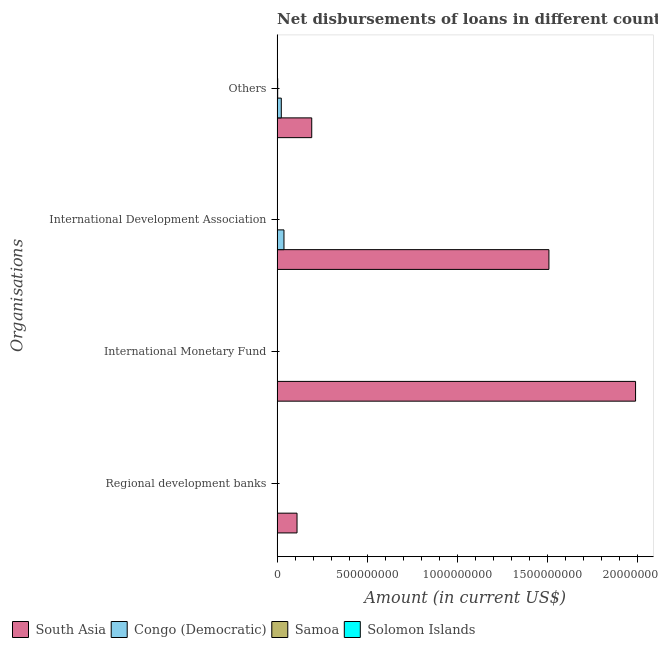How many different coloured bars are there?
Give a very brief answer. 4. How many groups of bars are there?
Provide a short and direct response. 4. How many bars are there on the 2nd tick from the bottom?
Your answer should be very brief. 2. What is the label of the 2nd group of bars from the top?
Keep it short and to the point. International Development Association. What is the amount of loan disimbursed by international monetary fund in Samoa?
Give a very brief answer. 0. Across all countries, what is the maximum amount of loan disimbursed by international development association?
Ensure brevity in your answer.  1.51e+09. Across all countries, what is the minimum amount of loan disimbursed by other organisations?
Provide a succinct answer. 2.20e+06. In which country was the amount of loan disimbursed by international monetary fund maximum?
Offer a terse response. South Asia. What is the total amount of loan disimbursed by international development association in the graph?
Your answer should be very brief. 1.55e+09. What is the difference between the amount of loan disimbursed by other organisations in South Asia and that in Solomon Islands?
Provide a succinct answer. 1.90e+08. What is the difference between the amount of loan disimbursed by regional development banks in Samoa and the amount of loan disimbursed by international development association in Congo (Democratic)?
Your answer should be compact. -3.67e+07. What is the average amount of loan disimbursed by international development association per country?
Make the answer very short. 3.87e+08. What is the difference between the amount of loan disimbursed by other organisations and amount of loan disimbursed by regional development banks in Congo (Democratic)?
Your answer should be very brief. 2.10e+07. In how many countries, is the amount of loan disimbursed by international monetary fund greater than 100000000 US$?
Your response must be concise. 1. What is the ratio of the amount of loan disimbursed by other organisations in South Asia to that in Congo (Democratic)?
Your answer should be very brief. 8.29. Is the difference between the amount of loan disimbursed by international development association in South Asia and Samoa greater than the difference between the amount of loan disimbursed by regional development banks in South Asia and Samoa?
Provide a short and direct response. Yes. What is the difference between the highest and the second highest amount of loan disimbursed by international development association?
Your response must be concise. 1.47e+09. What is the difference between the highest and the lowest amount of loan disimbursed by international monetary fund?
Offer a very short reply. 1.99e+09. Is the sum of the amount of loan disimbursed by other organisations in Congo (Democratic) and Solomon Islands greater than the maximum amount of loan disimbursed by regional development banks across all countries?
Your answer should be compact. No. Is it the case that in every country, the sum of the amount of loan disimbursed by other organisations and amount of loan disimbursed by international monetary fund is greater than the sum of amount of loan disimbursed by regional development banks and amount of loan disimbursed by international development association?
Offer a very short reply. No. Is it the case that in every country, the sum of the amount of loan disimbursed by regional development banks and amount of loan disimbursed by international monetary fund is greater than the amount of loan disimbursed by international development association?
Offer a terse response. No. How many countries are there in the graph?
Your answer should be very brief. 4. What is the difference between two consecutive major ticks on the X-axis?
Provide a short and direct response. 5.00e+08. Does the graph contain any zero values?
Offer a very short reply. Yes. Where does the legend appear in the graph?
Provide a short and direct response. Bottom left. How many legend labels are there?
Keep it short and to the point. 4. What is the title of the graph?
Offer a terse response. Net disbursements of loans in different countries in 1982. Does "Europe(all income levels)" appear as one of the legend labels in the graph?
Make the answer very short. No. What is the label or title of the Y-axis?
Provide a succinct answer. Organisations. What is the Amount (in current US$) of South Asia in Regional development banks?
Offer a very short reply. 1.10e+08. What is the Amount (in current US$) of Congo (Democratic) in Regional development banks?
Offer a terse response. 2.10e+06. What is the Amount (in current US$) in Samoa in Regional development banks?
Offer a very short reply. 1.19e+06. What is the Amount (in current US$) in Solomon Islands in Regional development banks?
Your answer should be very brief. 1.82e+06. What is the Amount (in current US$) of South Asia in International Monetary Fund?
Provide a succinct answer. 1.99e+09. What is the Amount (in current US$) in Congo (Democratic) in International Monetary Fund?
Your answer should be very brief. 0. What is the Amount (in current US$) in Samoa in International Monetary Fund?
Keep it short and to the point. 0. What is the Amount (in current US$) of Solomon Islands in International Monetary Fund?
Your response must be concise. 1.77e+06. What is the Amount (in current US$) in South Asia in International Development Association?
Provide a succinct answer. 1.51e+09. What is the Amount (in current US$) in Congo (Democratic) in International Development Association?
Your answer should be compact. 3.79e+07. What is the Amount (in current US$) of Samoa in International Development Association?
Offer a very short reply. 1.09e+06. What is the Amount (in current US$) of Solomon Islands in International Development Association?
Offer a terse response. 1.02e+05. What is the Amount (in current US$) in South Asia in Others?
Offer a very short reply. 1.92e+08. What is the Amount (in current US$) in Congo (Democratic) in Others?
Ensure brevity in your answer.  2.31e+07. What is the Amount (in current US$) in Samoa in Others?
Ensure brevity in your answer.  3.11e+06. What is the Amount (in current US$) of Solomon Islands in Others?
Offer a very short reply. 2.20e+06. Across all Organisations, what is the maximum Amount (in current US$) of South Asia?
Offer a terse response. 1.99e+09. Across all Organisations, what is the maximum Amount (in current US$) in Congo (Democratic)?
Give a very brief answer. 3.79e+07. Across all Organisations, what is the maximum Amount (in current US$) in Samoa?
Provide a short and direct response. 3.11e+06. Across all Organisations, what is the maximum Amount (in current US$) of Solomon Islands?
Your answer should be compact. 2.20e+06. Across all Organisations, what is the minimum Amount (in current US$) in South Asia?
Offer a terse response. 1.10e+08. Across all Organisations, what is the minimum Amount (in current US$) of Congo (Democratic)?
Your response must be concise. 0. Across all Organisations, what is the minimum Amount (in current US$) of Solomon Islands?
Your answer should be compact. 1.02e+05. What is the total Amount (in current US$) of South Asia in the graph?
Give a very brief answer. 3.80e+09. What is the total Amount (in current US$) in Congo (Democratic) in the graph?
Provide a succinct answer. 6.32e+07. What is the total Amount (in current US$) of Samoa in the graph?
Your answer should be very brief. 5.39e+06. What is the total Amount (in current US$) of Solomon Islands in the graph?
Your response must be concise. 5.89e+06. What is the difference between the Amount (in current US$) of South Asia in Regional development banks and that in International Monetary Fund?
Provide a short and direct response. -1.88e+09. What is the difference between the Amount (in current US$) of Solomon Islands in Regional development banks and that in International Monetary Fund?
Your response must be concise. 5.20e+04. What is the difference between the Amount (in current US$) of South Asia in Regional development banks and that in International Development Association?
Make the answer very short. -1.40e+09. What is the difference between the Amount (in current US$) of Congo (Democratic) in Regional development banks and that in International Development Association?
Your answer should be very brief. -3.58e+07. What is the difference between the Amount (in current US$) of Solomon Islands in Regional development banks and that in International Development Association?
Ensure brevity in your answer.  1.72e+06. What is the difference between the Amount (in current US$) in South Asia in Regional development banks and that in Others?
Give a very brief answer. -8.16e+07. What is the difference between the Amount (in current US$) of Congo (Democratic) in Regional development banks and that in Others?
Offer a terse response. -2.10e+07. What is the difference between the Amount (in current US$) of Samoa in Regional development banks and that in Others?
Give a very brief answer. -1.92e+06. What is the difference between the Amount (in current US$) in Solomon Islands in Regional development banks and that in Others?
Provide a short and direct response. -3.76e+05. What is the difference between the Amount (in current US$) of South Asia in International Monetary Fund and that in International Development Association?
Your answer should be compact. 4.80e+08. What is the difference between the Amount (in current US$) of Solomon Islands in International Monetary Fund and that in International Development Association?
Provide a succinct answer. 1.67e+06. What is the difference between the Amount (in current US$) in South Asia in International Monetary Fund and that in Others?
Offer a very short reply. 1.80e+09. What is the difference between the Amount (in current US$) of Solomon Islands in International Monetary Fund and that in Others?
Provide a succinct answer. -4.28e+05. What is the difference between the Amount (in current US$) in South Asia in International Development Association and that in Others?
Make the answer very short. 1.32e+09. What is the difference between the Amount (in current US$) in Congo (Democratic) in International Development Association and that in Others?
Offer a terse response. 1.48e+07. What is the difference between the Amount (in current US$) in Samoa in International Development Association and that in Others?
Make the answer very short. -2.02e+06. What is the difference between the Amount (in current US$) in Solomon Islands in International Development Association and that in Others?
Offer a terse response. -2.09e+06. What is the difference between the Amount (in current US$) of South Asia in Regional development banks and the Amount (in current US$) of Solomon Islands in International Monetary Fund?
Keep it short and to the point. 1.09e+08. What is the difference between the Amount (in current US$) of Congo (Democratic) in Regional development banks and the Amount (in current US$) of Solomon Islands in International Monetary Fund?
Offer a very short reply. 3.33e+05. What is the difference between the Amount (in current US$) of Samoa in Regional development banks and the Amount (in current US$) of Solomon Islands in International Monetary Fund?
Your answer should be compact. -5.76e+05. What is the difference between the Amount (in current US$) in South Asia in Regional development banks and the Amount (in current US$) in Congo (Democratic) in International Development Association?
Your response must be concise. 7.24e+07. What is the difference between the Amount (in current US$) of South Asia in Regional development banks and the Amount (in current US$) of Samoa in International Development Association?
Provide a short and direct response. 1.09e+08. What is the difference between the Amount (in current US$) of South Asia in Regional development banks and the Amount (in current US$) of Solomon Islands in International Development Association?
Make the answer very short. 1.10e+08. What is the difference between the Amount (in current US$) of Congo (Democratic) in Regional development banks and the Amount (in current US$) of Samoa in International Development Association?
Make the answer very short. 1.01e+06. What is the difference between the Amount (in current US$) of Congo (Democratic) in Regional development banks and the Amount (in current US$) of Solomon Islands in International Development Association?
Your answer should be compact. 2.00e+06. What is the difference between the Amount (in current US$) of Samoa in Regional development banks and the Amount (in current US$) of Solomon Islands in International Development Association?
Make the answer very short. 1.09e+06. What is the difference between the Amount (in current US$) in South Asia in Regional development banks and the Amount (in current US$) in Congo (Democratic) in Others?
Keep it short and to the point. 8.72e+07. What is the difference between the Amount (in current US$) of South Asia in Regional development banks and the Amount (in current US$) of Samoa in Others?
Ensure brevity in your answer.  1.07e+08. What is the difference between the Amount (in current US$) in South Asia in Regional development banks and the Amount (in current US$) in Solomon Islands in Others?
Offer a very short reply. 1.08e+08. What is the difference between the Amount (in current US$) of Congo (Democratic) in Regional development banks and the Amount (in current US$) of Samoa in Others?
Offer a terse response. -1.01e+06. What is the difference between the Amount (in current US$) in Congo (Democratic) in Regional development banks and the Amount (in current US$) in Solomon Islands in Others?
Give a very brief answer. -9.50e+04. What is the difference between the Amount (in current US$) in Samoa in Regional development banks and the Amount (in current US$) in Solomon Islands in Others?
Provide a short and direct response. -1.00e+06. What is the difference between the Amount (in current US$) of South Asia in International Monetary Fund and the Amount (in current US$) of Congo (Democratic) in International Development Association?
Provide a succinct answer. 1.95e+09. What is the difference between the Amount (in current US$) of South Asia in International Monetary Fund and the Amount (in current US$) of Samoa in International Development Association?
Offer a very short reply. 1.99e+09. What is the difference between the Amount (in current US$) in South Asia in International Monetary Fund and the Amount (in current US$) in Solomon Islands in International Development Association?
Your answer should be compact. 1.99e+09. What is the difference between the Amount (in current US$) of South Asia in International Monetary Fund and the Amount (in current US$) of Congo (Democratic) in Others?
Offer a terse response. 1.96e+09. What is the difference between the Amount (in current US$) of South Asia in International Monetary Fund and the Amount (in current US$) of Samoa in Others?
Your answer should be very brief. 1.98e+09. What is the difference between the Amount (in current US$) in South Asia in International Monetary Fund and the Amount (in current US$) in Solomon Islands in Others?
Provide a short and direct response. 1.99e+09. What is the difference between the Amount (in current US$) in South Asia in International Development Association and the Amount (in current US$) in Congo (Democratic) in Others?
Give a very brief answer. 1.48e+09. What is the difference between the Amount (in current US$) of South Asia in International Development Association and the Amount (in current US$) of Samoa in Others?
Offer a terse response. 1.50e+09. What is the difference between the Amount (in current US$) of South Asia in International Development Association and the Amount (in current US$) of Solomon Islands in Others?
Your response must be concise. 1.50e+09. What is the difference between the Amount (in current US$) in Congo (Democratic) in International Development Association and the Amount (in current US$) in Samoa in Others?
Your answer should be compact. 3.48e+07. What is the difference between the Amount (in current US$) in Congo (Democratic) in International Development Association and the Amount (in current US$) in Solomon Islands in Others?
Keep it short and to the point. 3.57e+07. What is the difference between the Amount (in current US$) of Samoa in International Development Association and the Amount (in current US$) of Solomon Islands in Others?
Your response must be concise. -1.10e+06. What is the average Amount (in current US$) of South Asia per Organisations?
Provide a short and direct response. 9.49e+08. What is the average Amount (in current US$) of Congo (Democratic) per Organisations?
Your answer should be very brief. 1.58e+07. What is the average Amount (in current US$) of Samoa per Organisations?
Your answer should be compact. 1.35e+06. What is the average Amount (in current US$) in Solomon Islands per Organisations?
Your answer should be very brief. 1.47e+06. What is the difference between the Amount (in current US$) in South Asia and Amount (in current US$) in Congo (Democratic) in Regional development banks?
Keep it short and to the point. 1.08e+08. What is the difference between the Amount (in current US$) of South Asia and Amount (in current US$) of Samoa in Regional development banks?
Make the answer very short. 1.09e+08. What is the difference between the Amount (in current US$) in South Asia and Amount (in current US$) in Solomon Islands in Regional development banks?
Ensure brevity in your answer.  1.09e+08. What is the difference between the Amount (in current US$) of Congo (Democratic) and Amount (in current US$) of Samoa in Regional development banks?
Ensure brevity in your answer.  9.09e+05. What is the difference between the Amount (in current US$) of Congo (Democratic) and Amount (in current US$) of Solomon Islands in Regional development banks?
Offer a terse response. 2.81e+05. What is the difference between the Amount (in current US$) of Samoa and Amount (in current US$) of Solomon Islands in Regional development banks?
Offer a terse response. -6.28e+05. What is the difference between the Amount (in current US$) of South Asia and Amount (in current US$) of Solomon Islands in International Monetary Fund?
Your answer should be very brief. 1.99e+09. What is the difference between the Amount (in current US$) of South Asia and Amount (in current US$) of Congo (Democratic) in International Development Association?
Your answer should be compact. 1.47e+09. What is the difference between the Amount (in current US$) of South Asia and Amount (in current US$) of Samoa in International Development Association?
Provide a short and direct response. 1.51e+09. What is the difference between the Amount (in current US$) in South Asia and Amount (in current US$) in Solomon Islands in International Development Association?
Your answer should be very brief. 1.51e+09. What is the difference between the Amount (in current US$) in Congo (Democratic) and Amount (in current US$) in Samoa in International Development Association?
Give a very brief answer. 3.68e+07. What is the difference between the Amount (in current US$) in Congo (Democratic) and Amount (in current US$) in Solomon Islands in International Development Association?
Give a very brief answer. 3.78e+07. What is the difference between the Amount (in current US$) of Samoa and Amount (in current US$) of Solomon Islands in International Development Association?
Offer a very short reply. 9.90e+05. What is the difference between the Amount (in current US$) in South Asia and Amount (in current US$) in Congo (Democratic) in Others?
Ensure brevity in your answer.  1.69e+08. What is the difference between the Amount (in current US$) of South Asia and Amount (in current US$) of Samoa in Others?
Offer a very short reply. 1.89e+08. What is the difference between the Amount (in current US$) of South Asia and Amount (in current US$) of Solomon Islands in Others?
Give a very brief answer. 1.90e+08. What is the difference between the Amount (in current US$) of Congo (Democratic) and Amount (in current US$) of Samoa in Others?
Provide a succinct answer. 2.00e+07. What is the difference between the Amount (in current US$) of Congo (Democratic) and Amount (in current US$) of Solomon Islands in Others?
Your answer should be compact. 2.09e+07. What is the difference between the Amount (in current US$) in Samoa and Amount (in current US$) in Solomon Islands in Others?
Your answer should be compact. 9.14e+05. What is the ratio of the Amount (in current US$) in South Asia in Regional development banks to that in International Monetary Fund?
Your response must be concise. 0.06. What is the ratio of the Amount (in current US$) in Solomon Islands in Regional development banks to that in International Monetary Fund?
Keep it short and to the point. 1.03. What is the ratio of the Amount (in current US$) of South Asia in Regional development banks to that in International Development Association?
Keep it short and to the point. 0.07. What is the ratio of the Amount (in current US$) in Congo (Democratic) in Regional development banks to that in International Development Association?
Your answer should be very brief. 0.06. What is the ratio of the Amount (in current US$) of Samoa in Regional development banks to that in International Development Association?
Offer a terse response. 1.09. What is the ratio of the Amount (in current US$) in Solomon Islands in Regional development banks to that in International Development Association?
Provide a short and direct response. 17.84. What is the ratio of the Amount (in current US$) of South Asia in Regional development banks to that in Others?
Your answer should be very brief. 0.57. What is the ratio of the Amount (in current US$) of Congo (Democratic) in Regional development banks to that in Others?
Offer a terse response. 0.09. What is the ratio of the Amount (in current US$) of Samoa in Regional development banks to that in Others?
Provide a short and direct response. 0.38. What is the ratio of the Amount (in current US$) of Solomon Islands in Regional development banks to that in Others?
Keep it short and to the point. 0.83. What is the ratio of the Amount (in current US$) of South Asia in International Monetary Fund to that in International Development Association?
Your answer should be compact. 1.32. What is the ratio of the Amount (in current US$) in Solomon Islands in International Monetary Fund to that in International Development Association?
Keep it short and to the point. 17.33. What is the ratio of the Amount (in current US$) of South Asia in International Monetary Fund to that in Others?
Provide a succinct answer. 10.36. What is the ratio of the Amount (in current US$) in Solomon Islands in International Monetary Fund to that in Others?
Your response must be concise. 0.81. What is the ratio of the Amount (in current US$) of South Asia in International Development Association to that in Others?
Offer a terse response. 7.85. What is the ratio of the Amount (in current US$) in Congo (Democratic) in International Development Association to that in Others?
Make the answer very short. 1.64. What is the ratio of the Amount (in current US$) in Samoa in International Development Association to that in Others?
Offer a terse response. 0.35. What is the ratio of the Amount (in current US$) of Solomon Islands in International Development Association to that in Others?
Give a very brief answer. 0.05. What is the difference between the highest and the second highest Amount (in current US$) in South Asia?
Your response must be concise. 4.80e+08. What is the difference between the highest and the second highest Amount (in current US$) of Congo (Democratic)?
Keep it short and to the point. 1.48e+07. What is the difference between the highest and the second highest Amount (in current US$) in Samoa?
Ensure brevity in your answer.  1.92e+06. What is the difference between the highest and the second highest Amount (in current US$) in Solomon Islands?
Ensure brevity in your answer.  3.76e+05. What is the difference between the highest and the lowest Amount (in current US$) in South Asia?
Provide a succinct answer. 1.88e+09. What is the difference between the highest and the lowest Amount (in current US$) of Congo (Democratic)?
Give a very brief answer. 3.79e+07. What is the difference between the highest and the lowest Amount (in current US$) in Samoa?
Your answer should be compact. 3.11e+06. What is the difference between the highest and the lowest Amount (in current US$) of Solomon Islands?
Provide a succinct answer. 2.09e+06. 